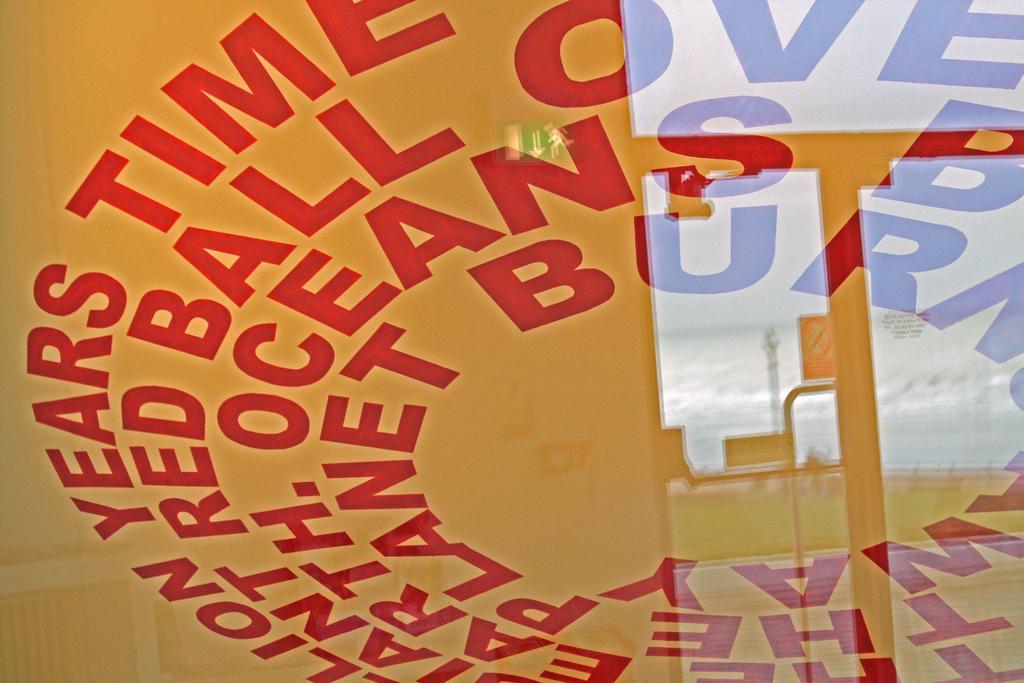What color is the text that's circling around?
Make the answer very short. Red. What color of ball does the text mention?
Make the answer very short. Red. 